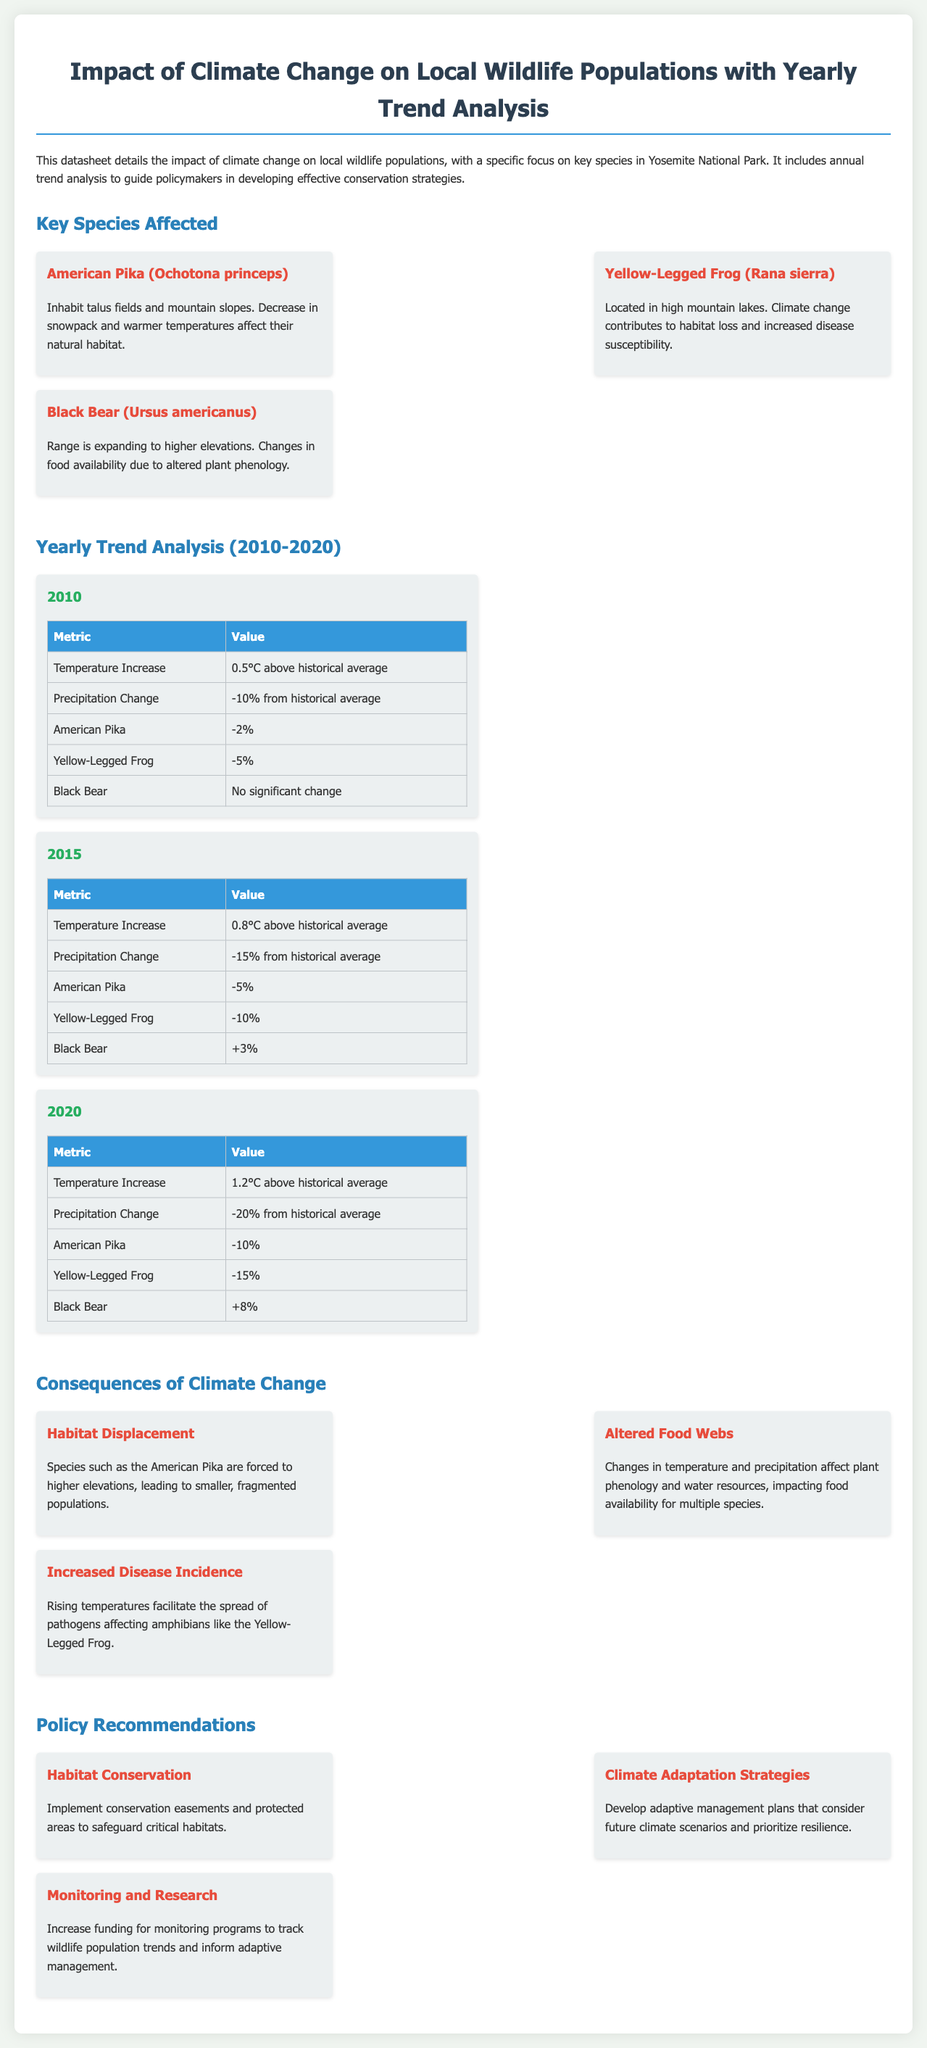What are the names of the three key species affected? The document lists American Pika, Yellow-Legged Frog, and Black Bear as the key species affected by climate change.
Answer: American Pika, Yellow-Legged Frog, Black Bear What was the temperature increase in 2015? According to the trend analysis for 2015, the temperature increase was noted as 0.8 degrees Celsius above the historical average.
Answer: 0.8°C above historical average What percentage change did the Yellow-Legged Frog experience by 2020? The annual trend analysis shows that the Yellow-Legged Frog population decreased by 15% by 2020.
Answer: -15% What is one consequence of climate change mentioned? The document highlights several consequences, specifically mentioning Habitat Displacement, Altered Food Webs, and Increased Disease Incidence.
Answer: Habitat Displacement What policy recommendation emphasizes monitoring? The recommendation focuses on increasing funding for monitoring programs to track wildlife population trends and inform adaptive management.
Answer: Monitoring and Research What was the precipitation change in 2020? The trend analysis indicates that the precipitation change by 2020 was a decrease of 20% from the historical average.
Answer: -20% from historical average In what year did the Black Bear population see a significant change? The trend analysis indicates significant change for the Black Bear population occurred in 2020, where it increased by 8%.
Answer: 2020 How many recommendations are provided in the policy section? The document lists three policy recommendations for conservation strategies to implement.
Answer: Three recommendations 